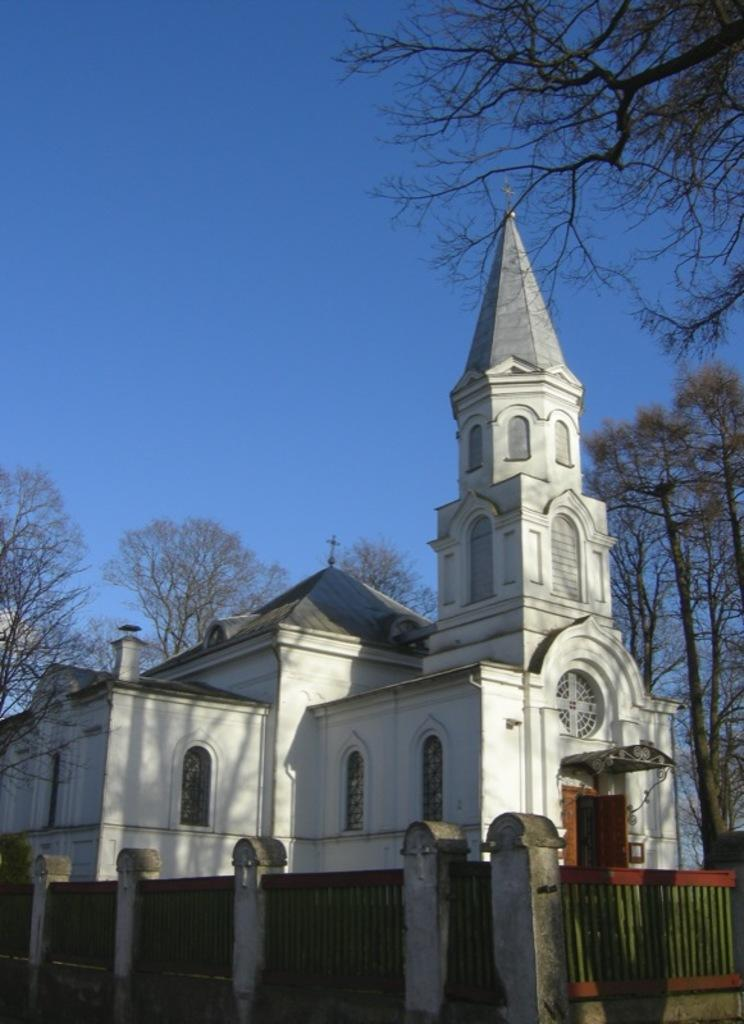What type of structure is present in the image? There is a building in the image. What surrounds the building? There is a compound wall in the image. What type of vegetation can be seen in the image? There are trees in the image. What is visible at the top of the image? The sky is visible at the top of the image, and it is blue. Can you see any notes being passed between the trees in the image? There are no notes or people visible in the image; it only features a building, a compound wall, trees, and a blue sky. Are there any geese or snakes present in the image? There are no geese or snakes present in the image; it only features a building, a compound wall, trees, and a blue sky. 